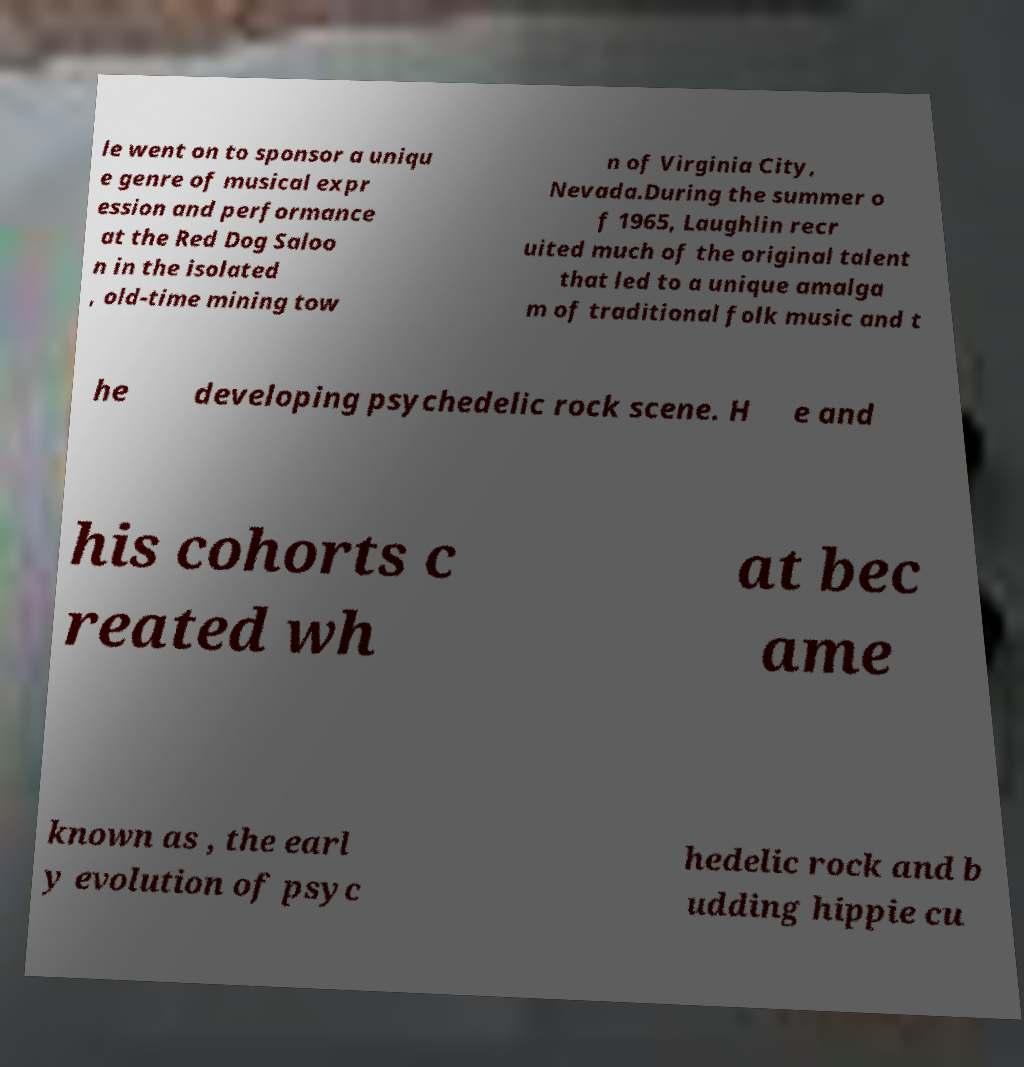There's text embedded in this image that I need extracted. Can you transcribe it verbatim? le went on to sponsor a uniqu e genre of musical expr ession and performance at the Red Dog Saloo n in the isolated , old-time mining tow n of Virginia City, Nevada.During the summer o f 1965, Laughlin recr uited much of the original talent that led to a unique amalga m of traditional folk music and t he developing psychedelic rock scene. H e and his cohorts c reated wh at bec ame known as , the earl y evolution of psyc hedelic rock and b udding hippie cu 